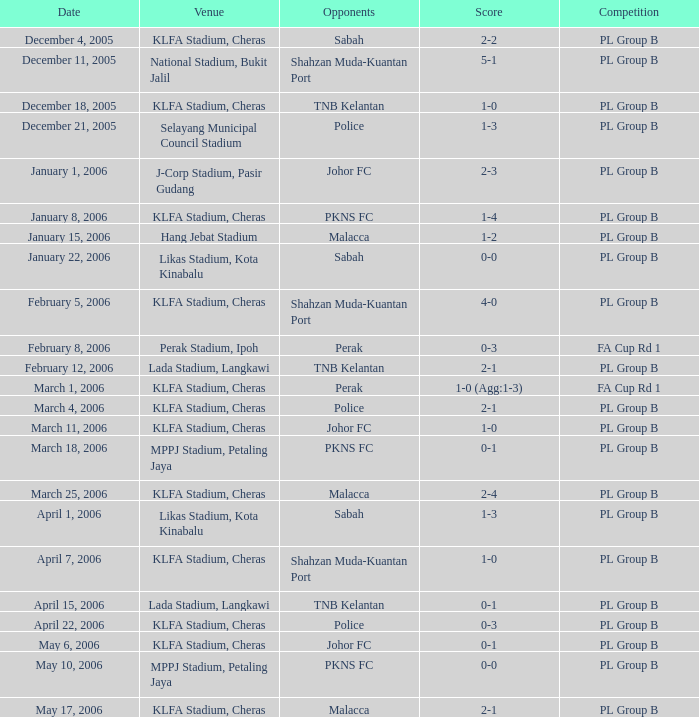Which tournament features a 0-1 score, and rivals of pkns fc? PL Group B. 